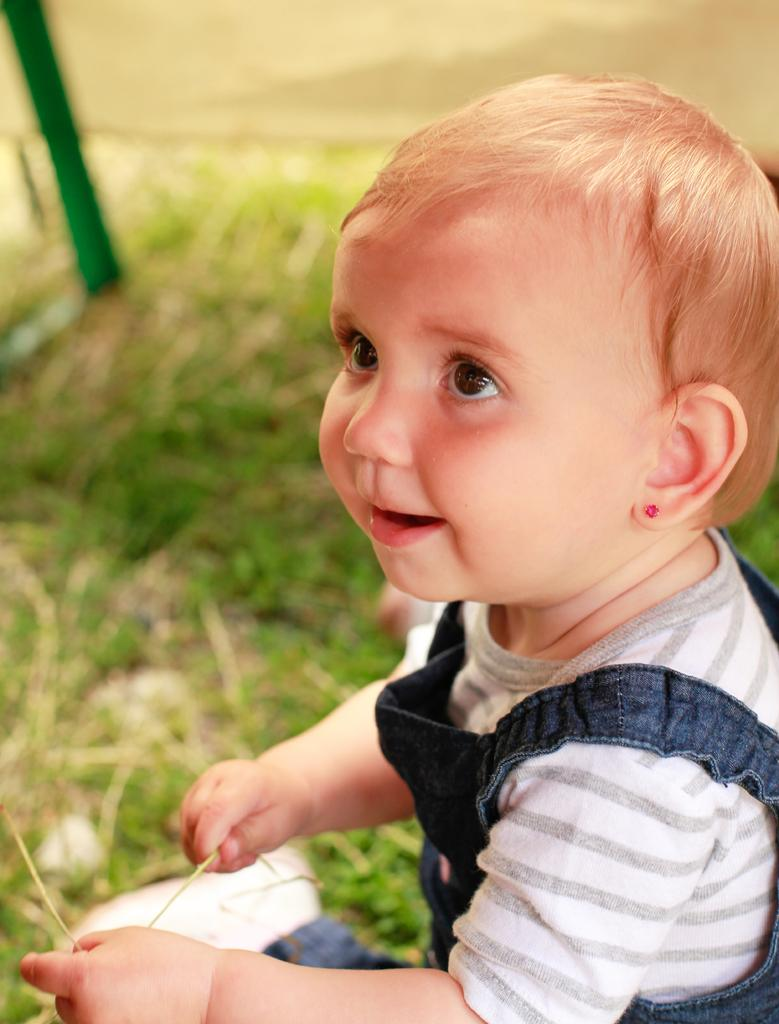What is the main subject of the image? There is a baby in the image. What is the baby holding in her hand? The baby is holding an object in her hand. What can be seen on the ground beside the baby? There is greenery on the ground beside the baby. Can you describe the object in the left top corner of the image? There is a green color object in the left top corner of the image. What type of carriage can be seen in the image? There is no carriage present in the image. Can you tell me how many yaks are visible in the image? There are no yaks present in the image. 